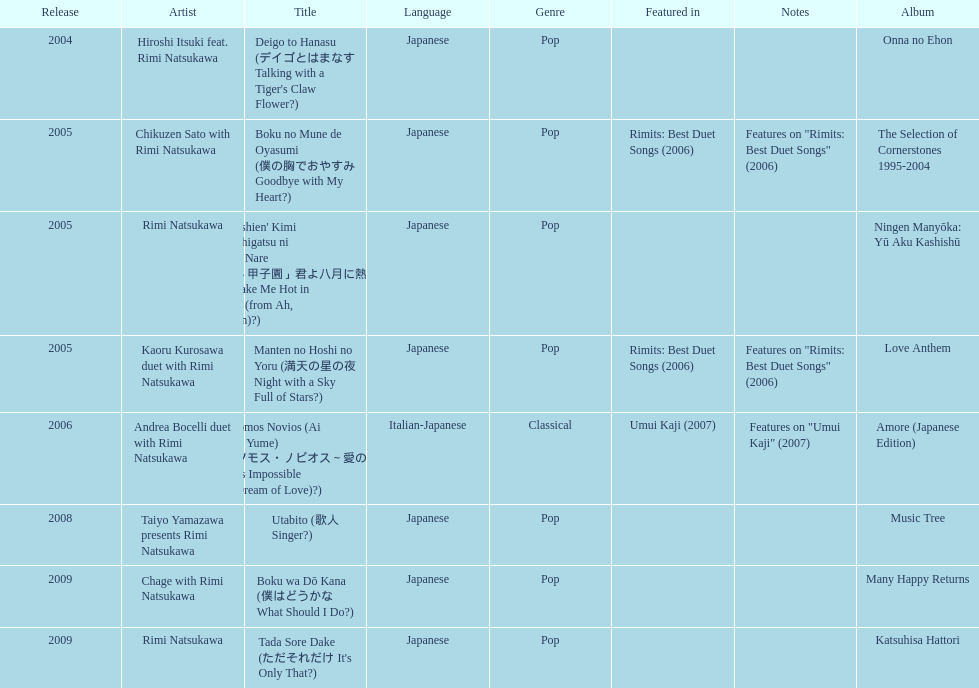What song was this artist on after utabito? Boku wa Dō Kana. 